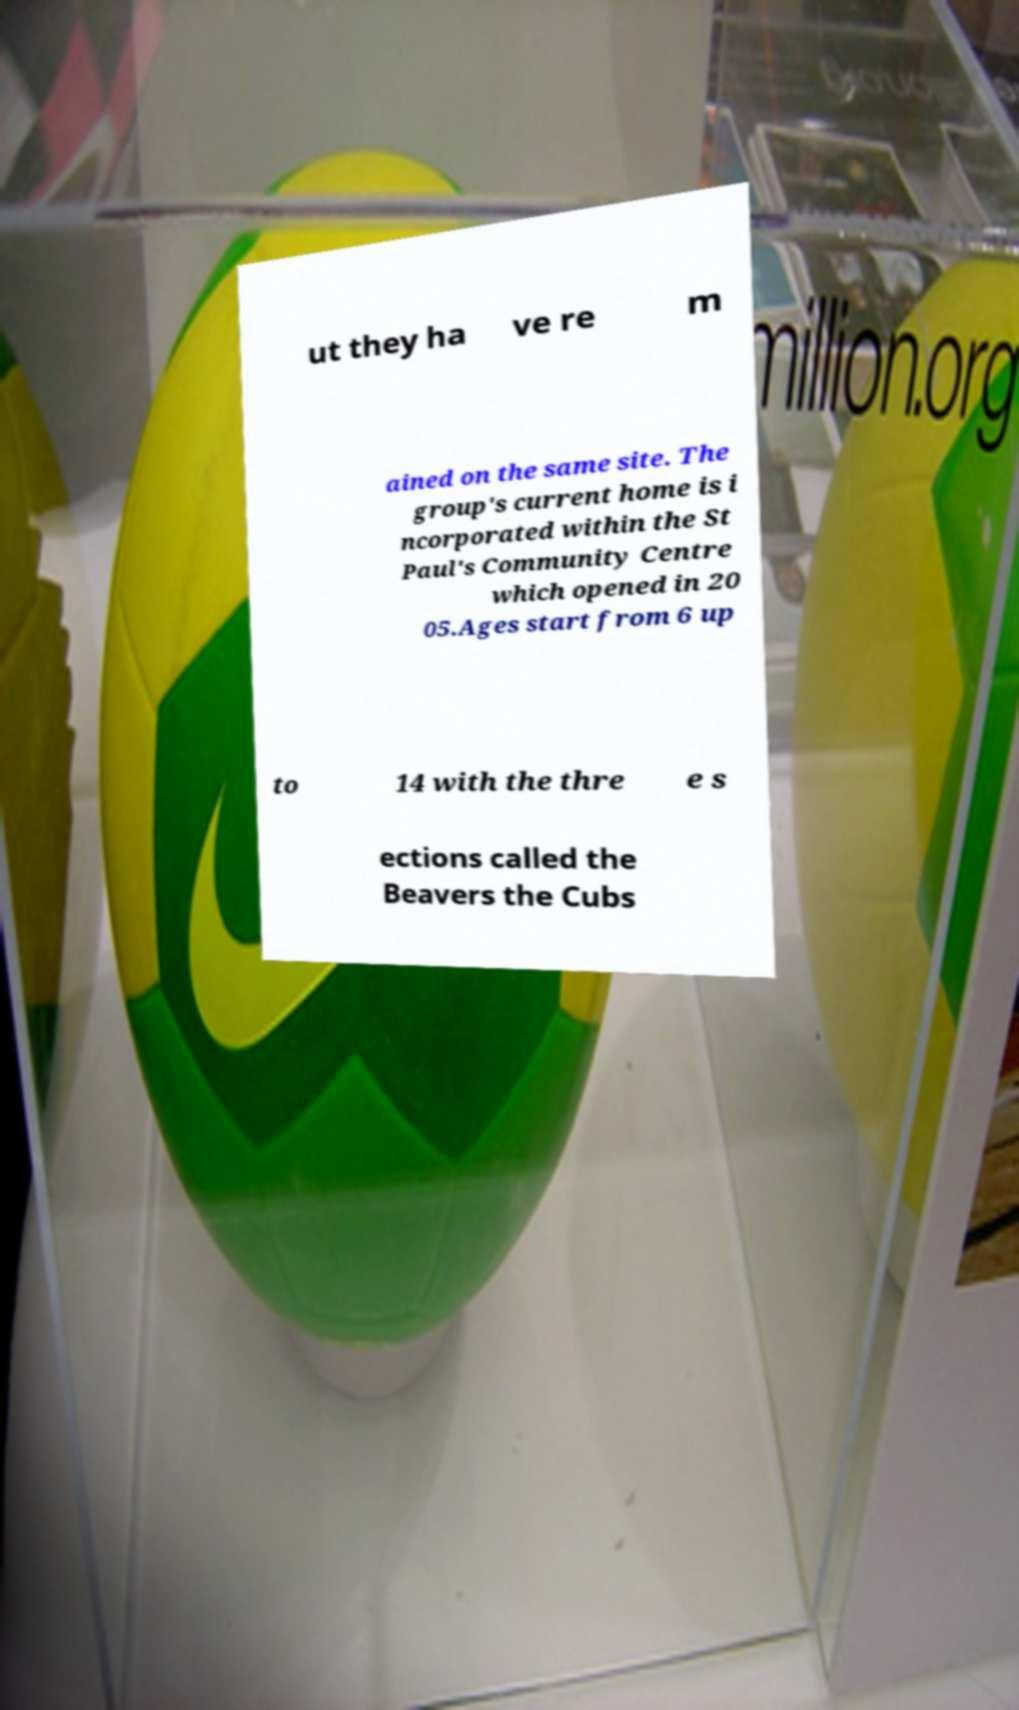Could you assist in decoding the text presented in this image and type it out clearly? ut they ha ve re m ained on the same site. The group's current home is i ncorporated within the St Paul's Community Centre which opened in 20 05.Ages start from 6 up to 14 with the thre e s ections called the Beavers the Cubs 